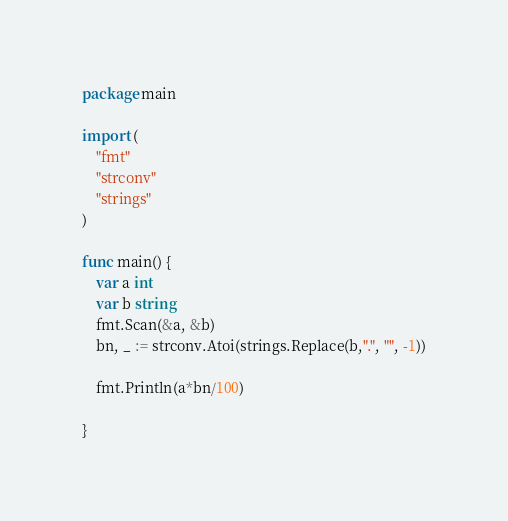<code> <loc_0><loc_0><loc_500><loc_500><_Go_>package main

import (
	"fmt"
	"strconv"
	"strings"
)

func main() {
	var a int
	var b string
	fmt.Scan(&a, &b)
	bn, _ := strconv.Atoi(strings.Replace(b,".", "", -1))

	fmt.Println(a*bn/100)

}

</code> 